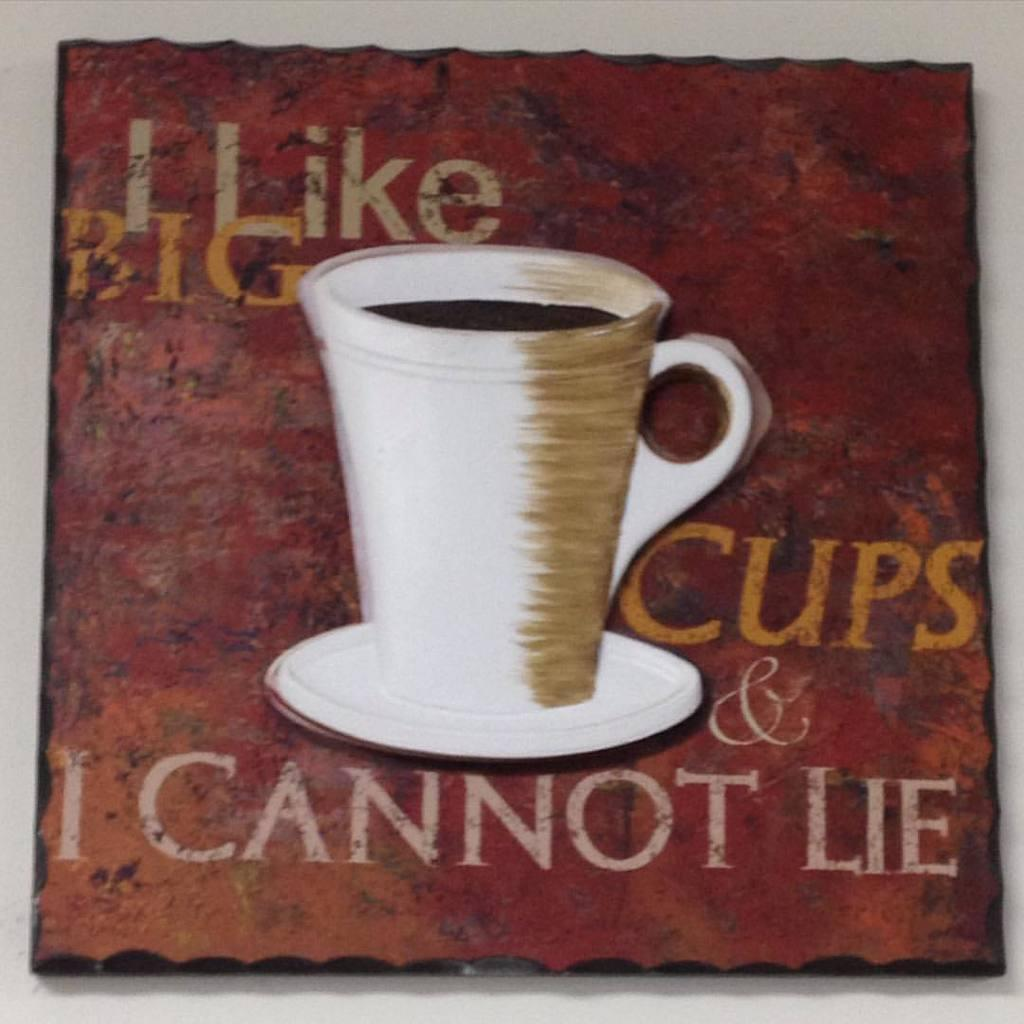<image>
Relay a brief, clear account of the picture shown. A photo of a coffee cup features the words, "I like big cups and I cannot lie." 